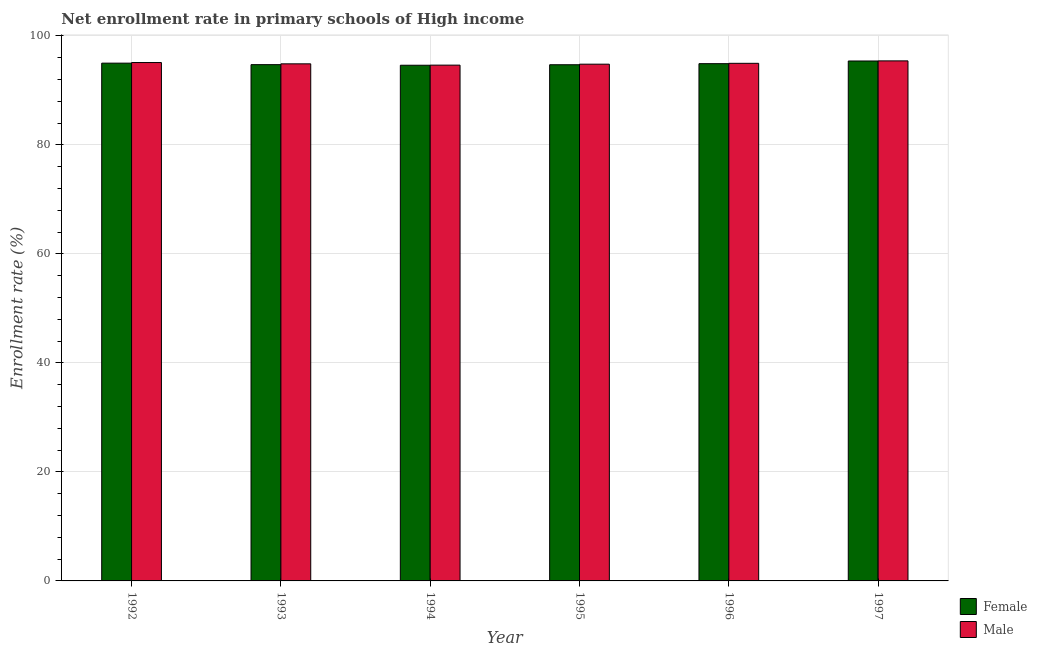What is the label of the 2nd group of bars from the left?
Your response must be concise. 1993. What is the enrollment rate of male students in 1992?
Ensure brevity in your answer.  95.1. Across all years, what is the maximum enrollment rate of male students?
Make the answer very short. 95.4. Across all years, what is the minimum enrollment rate of male students?
Offer a terse response. 94.62. What is the total enrollment rate of female students in the graph?
Provide a short and direct response. 569.27. What is the difference between the enrollment rate of male students in 1995 and that in 1996?
Give a very brief answer. -0.16. What is the difference between the enrollment rate of female students in 1997 and the enrollment rate of male students in 1992?
Provide a short and direct response. 0.39. What is the average enrollment rate of male students per year?
Your answer should be compact. 94.96. In how many years, is the enrollment rate of female students greater than 12 %?
Make the answer very short. 6. What is the ratio of the enrollment rate of male students in 1995 to that in 1996?
Your response must be concise. 1. Is the enrollment rate of male students in 1994 less than that in 1997?
Make the answer very short. Yes. What is the difference between the highest and the second highest enrollment rate of female students?
Your response must be concise. 0.39. What is the difference between the highest and the lowest enrollment rate of male students?
Make the answer very short. 0.78. In how many years, is the enrollment rate of female students greater than the average enrollment rate of female students taken over all years?
Your response must be concise. 3. Is the sum of the enrollment rate of female students in 1994 and 1996 greater than the maximum enrollment rate of male students across all years?
Ensure brevity in your answer.  Yes. What does the 1st bar from the right in 1994 represents?
Ensure brevity in your answer.  Male. What is the difference between two consecutive major ticks on the Y-axis?
Offer a very short reply. 20. Does the graph contain grids?
Provide a short and direct response. Yes. How are the legend labels stacked?
Offer a terse response. Vertical. What is the title of the graph?
Offer a terse response. Net enrollment rate in primary schools of High income. What is the label or title of the Y-axis?
Keep it short and to the point. Enrollment rate (%). What is the Enrollment rate (%) in Female in 1992?
Make the answer very short. 94.99. What is the Enrollment rate (%) of Male in 1992?
Provide a short and direct response. 95.1. What is the Enrollment rate (%) of Female in 1993?
Your answer should be very brief. 94.71. What is the Enrollment rate (%) in Male in 1993?
Offer a terse response. 94.86. What is the Enrollment rate (%) of Female in 1994?
Make the answer very short. 94.6. What is the Enrollment rate (%) in Male in 1994?
Your answer should be very brief. 94.62. What is the Enrollment rate (%) of Female in 1995?
Offer a very short reply. 94.69. What is the Enrollment rate (%) of Male in 1995?
Keep it short and to the point. 94.8. What is the Enrollment rate (%) in Female in 1996?
Provide a short and direct response. 94.89. What is the Enrollment rate (%) of Male in 1996?
Give a very brief answer. 94.95. What is the Enrollment rate (%) of Female in 1997?
Offer a very short reply. 95.38. What is the Enrollment rate (%) in Male in 1997?
Offer a very short reply. 95.4. Across all years, what is the maximum Enrollment rate (%) in Female?
Your answer should be compact. 95.38. Across all years, what is the maximum Enrollment rate (%) of Male?
Your answer should be very brief. 95.4. Across all years, what is the minimum Enrollment rate (%) of Female?
Keep it short and to the point. 94.6. Across all years, what is the minimum Enrollment rate (%) of Male?
Your answer should be compact. 94.62. What is the total Enrollment rate (%) of Female in the graph?
Keep it short and to the point. 569.27. What is the total Enrollment rate (%) of Male in the graph?
Make the answer very short. 569.73. What is the difference between the Enrollment rate (%) in Female in 1992 and that in 1993?
Make the answer very short. 0.28. What is the difference between the Enrollment rate (%) in Male in 1992 and that in 1993?
Keep it short and to the point. 0.24. What is the difference between the Enrollment rate (%) of Female in 1992 and that in 1994?
Give a very brief answer. 0.38. What is the difference between the Enrollment rate (%) of Male in 1992 and that in 1994?
Keep it short and to the point. 0.47. What is the difference between the Enrollment rate (%) in Female in 1992 and that in 1995?
Ensure brevity in your answer.  0.29. What is the difference between the Enrollment rate (%) in Male in 1992 and that in 1995?
Keep it short and to the point. 0.3. What is the difference between the Enrollment rate (%) in Female in 1992 and that in 1996?
Ensure brevity in your answer.  0.1. What is the difference between the Enrollment rate (%) in Male in 1992 and that in 1996?
Offer a very short reply. 0.14. What is the difference between the Enrollment rate (%) in Female in 1992 and that in 1997?
Provide a short and direct response. -0.39. What is the difference between the Enrollment rate (%) in Male in 1992 and that in 1997?
Your answer should be compact. -0.31. What is the difference between the Enrollment rate (%) in Female in 1993 and that in 1994?
Offer a very short reply. 0.11. What is the difference between the Enrollment rate (%) in Male in 1993 and that in 1994?
Offer a terse response. 0.24. What is the difference between the Enrollment rate (%) of Female in 1993 and that in 1995?
Make the answer very short. 0.02. What is the difference between the Enrollment rate (%) in Male in 1993 and that in 1995?
Keep it short and to the point. 0.06. What is the difference between the Enrollment rate (%) of Female in 1993 and that in 1996?
Offer a very short reply. -0.18. What is the difference between the Enrollment rate (%) in Male in 1993 and that in 1996?
Keep it short and to the point. -0.1. What is the difference between the Enrollment rate (%) of Female in 1993 and that in 1997?
Your answer should be compact. -0.67. What is the difference between the Enrollment rate (%) of Male in 1993 and that in 1997?
Ensure brevity in your answer.  -0.54. What is the difference between the Enrollment rate (%) of Female in 1994 and that in 1995?
Your answer should be compact. -0.09. What is the difference between the Enrollment rate (%) of Male in 1994 and that in 1995?
Provide a succinct answer. -0.17. What is the difference between the Enrollment rate (%) in Female in 1994 and that in 1996?
Provide a short and direct response. -0.29. What is the difference between the Enrollment rate (%) in Male in 1994 and that in 1996?
Provide a short and direct response. -0.33. What is the difference between the Enrollment rate (%) in Female in 1994 and that in 1997?
Your answer should be compact. -0.78. What is the difference between the Enrollment rate (%) in Male in 1994 and that in 1997?
Give a very brief answer. -0.78. What is the difference between the Enrollment rate (%) of Female in 1995 and that in 1996?
Give a very brief answer. -0.2. What is the difference between the Enrollment rate (%) in Male in 1995 and that in 1996?
Ensure brevity in your answer.  -0.16. What is the difference between the Enrollment rate (%) in Female in 1995 and that in 1997?
Provide a succinct answer. -0.69. What is the difference between the Enrollment rate (%) of Male in 1995 and that in 1997?
Your response must be concise. -0.61. What is the difference between the Enrollment rate (%) in Female in 1996 and that in 1997?
Ensure brevity in your answer.  -0.49. What is the difference between the Enrollment rate (%) of Male in 1996 and that in 1997?
Your answer should be very brief. -0.45. What is the difference between the Enrollment rate (%) in Female in 1992 and the Enrollment rate (%) in Male in 1993?
Give a very brief answer. 0.13. What is the difference between the Enrollment rate (%) of Female in 1992 and the Enrollment rate (%) of Male in 1994?
Make the answer very short. 0.36. What is the difference between the Enrollment rate (%) in Female in 1992 and the Enrollment rate (%) in Male in 1995?
Your response must be concise. 0.19. What is the difference between the Enrollment rate (%) in Female in 1992 and the Enrollment rate (%) in Male in 1996?
Keep it short and to the point. 0.03. What is the difference between the Enrollment rate (%) in Female in 1992 and the Enrollment rate (%) in Male in 1997?
Provide a short and direct response. -0.42. What is the difference between the Enrollment rate (%) in Female in 1993 and the Enrollment rate (%) in Male in 1994?
Offer a very short reply. 0.09. What is the difference between the Enrollment rate (%) of Female in 1993 and the Enrollment rate (%) of Male in 1995?
Offer a terse response. -0.09. What is the difference between the Enrollment rate (%) of Female in 1993 and the Enrollment rate (%) of Male in 1996?
Offer a very short reply. -0.24. What is the difference between the Enrollment rate (%) in Female in 1993 and the Enrollment rate (%) in Male in 1997?
Your response must be concise. -0.69. What is the difference between the Enrollment rate (%) of Female in 1994 and the Enrollment rate (%) of Male in 1995?
Make the answer very short. -0.19. What is the difference between the Enrollment rate (%) of Female in 1994 and the Enrollment rate (%) of Male in 1996?
Your answer should be very brief. -0.35. What is the difference between the Enrollment rate (%) of Female in 1994 and the Enrollment rate (%) of Male in 1997?
Keep it short and to the point. -0.8. What is the difference between the Enrollment rate (%) in Female in 1995 and the Enrollment rate (%) in Male in 1996?
Offer a terse response. -0.26. What is the difference between the Enrollment rate (%) of Female in 1995 and the Enrollment rate (%) of Male in 1997?
Provide a succinct answer. -0.71. What is the difference between the Enrollment rate (%) in Female in 1996 and the Enrollment rate (%) in Male in 1997?
Your answer should be very brief. -0.51. What is the average Enrollment rate (%) in Female per year?
Make the answer very short. 94.88. What is the average Enrollment rate (%) in Male per year?
Offer a terse response. 94.96. In the year 1992, what is the difference between the Enrollment rate (%) in Female and Enrollment rate (%) in Male?
Keep it short and to the point. -0.11. In the year 1993, what is the difference between the Enrollment rate (%) of Female and Enrollment rate (%) of Male?
Your answer should be compact. -0.15. In the year 1994, what is the difference between the Enrollment rate (%) of Female and Enrollment rate (%) of Male?
Provide a short and direct response. -0.02. In the year 1995, what is the difference between the Enrollment rate (%) in Female and Enrollment rate (%) in Male?
Ensure brevity in your answer.  -0.1. In the year 1996, what is the difference between the Enrollment rate (%) in Female and Enrollment rate (%) in Male?
Keep it short and to the point. -0.06. In the year 1997, what is the difference between the Enrollment rate (%) in Female and Enrollment rate (%) in Male?
Ensure brevity in your answer.  -0.02. What is the ratio of the Enrollment rate (%) in Female in 1992 to that in 1993?
Your answer should be compact. 1. What is the ratio of the Enrollment rate (%) of Male in 1992 to that in 1993?
Offer a very short reply. 1. What is the ratio of the Enrollment rate (%) of Female in 1992 to that in 1994?
Offer a very short reply. 1. What is the ratio of the Enrollment rate (%) in Female in 1992 to that in 1995?
Your answer should be compact. 1. What is the ratio of the Enrollment rate (%) of Male in 1992 to that in 1996?
Make the answer very short. 1. What is the ratio of the Enrollment rate (%) of Female in 1992 to that in 1997?
Keep it short and to the point. 1. What is the ratio of the Enrollment rate (%) of Male in 1993 to that in 1994?
Offer a very short reply. 1. What is the ratio of the Enrollment rate (%) of Female in 1993 to that in 1995?
Your answer should be very brief. 1. What is the ratio of the Enrollment rate (%) in Female in 1993 to that in 1997?
Offer a terse response. 0.99. What is the ratio of the Enrollment rate (%) of Male in 1993 to that in 1997?
Keep it short and to the point. 0.99. What is the ratio of the Enrollment rate (%) in Male in 1994 to that in 1995?
Make the answer very short. 1. What is the ratio of the Enrollment rate (%) of Female in 1994 to that in 1997?
Provide a succinct answer. 0.99. What is the ratio of the Enrollment rate (%) in Male in 1994 to that in 1997?
Provide a short and direct response. 0.99. What is the ratio of the Enrollment rate (%) of Female in 1995 to that in 1996?
Make the answer very short. 1. What is the ratio of the Enrollment rate (%) of Female in 1995 to that in 1997?
Offer a very short reply. 0.99. What is the difference between the highest and the second highest Enrollment rate (%) of Female?
Make the answer very short. 0.39. What is the difference between the highest and the second highest Enrollment rate (%) in Male?
Your answer should be very brief. 0.31. What is the difference between the highest and the lowest Enrollment rate (%) of Female?
Your response must be concise. 0.78. What is the difference between the highest and the lowest Enrollment rate (%) of Male?
Give a very brief answer. 0.78. 